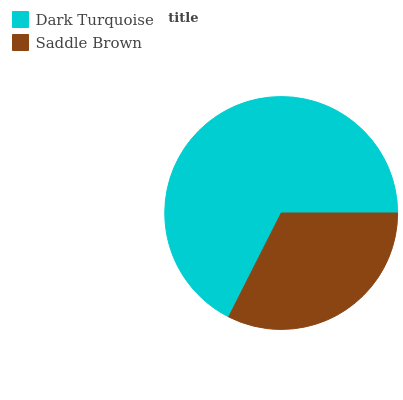Is Saddle Brown the minimum?
Answer yes or no. Yes. Is Dark Turquoise the maximum?
Answer yes or no. Yes. Is Saddle Brown the maximum?
Answer yes or no. No. Is Dark Turquoise greater than Saddle Brown?
Answer yes or no. Yes. Is Saddle Brown less than Dark Turquoise?
Answer yes or no. Yes. Is Saddle Brown greater than Dark Turquoise?
Answer yes or no. No. Is Dark Turquoise less than Saddle Brown?
Answer yes or no. No. Is Dark Turquoise the high median?
Answer yes or no. Yes. Is Saddle Brown the low median?
Answer yes or no. Yes. Is Saddle Brown the high median?
Answer yes or no. No. Is Dark Turquoise the low median?
Answer yes or no. No. 